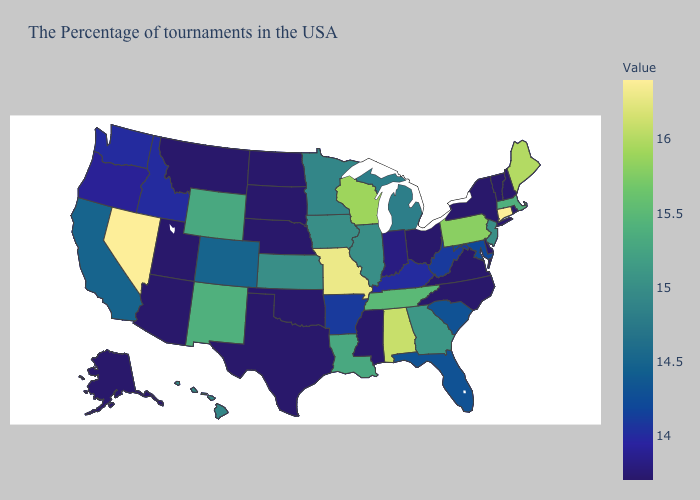Does the map have missing data?
Keep it brief. No. Does the map have missing data?
Keep it brief. No. Does Tennessee have the highest value in the South?
Be succinct. No. Does Connecticut have the lowest value in the Northeast?
Keep it brief. No. Does Georgia have the lowest value in the South?
Short answer required. No. Is the legend a continuous bar?
Concise answer only. Yes. Among the states that border Washington , does Oregon have the lowest value?
Quick response, please. Yes. Does Wisconsin have a higher value than Maryland?
Answer briefly. Yes. Does Michigan have the highest value in the USA?
Quick response, please. No. 